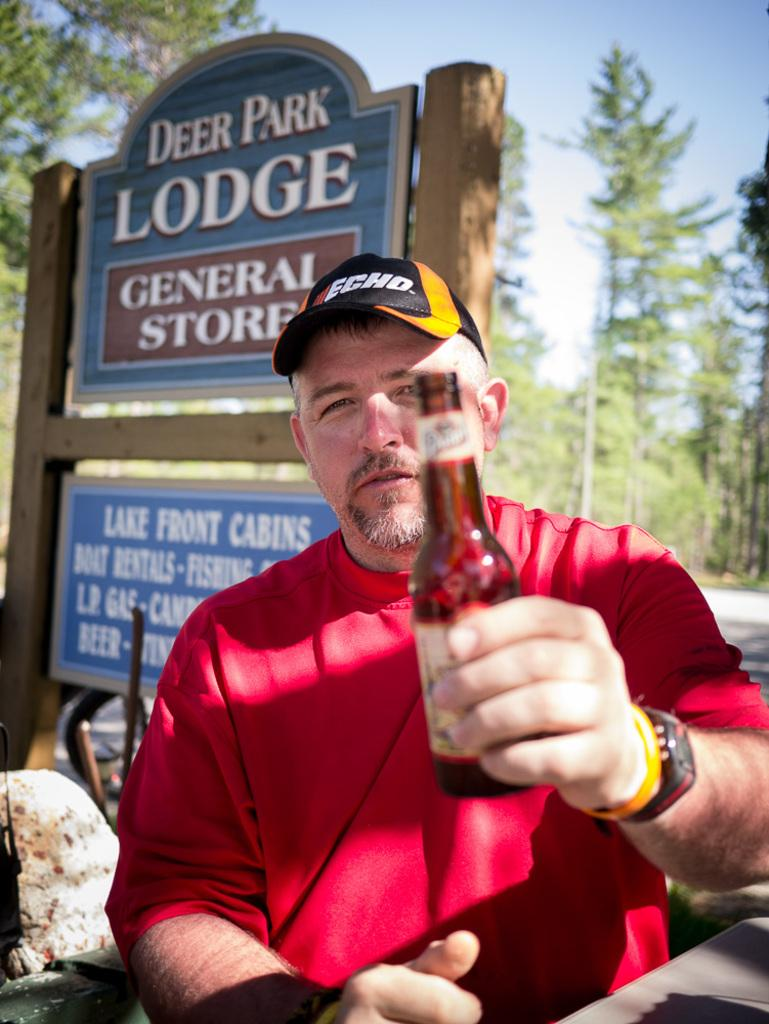What is the person in the image doing? The person is sitting in the image. What is the person holding in the image? The person is holding a bottle in the image. What type of headwear is the person wearing? The person is wearing a cap in the image. What can be seen in the background of the image? There is a board, trees, and the sky visible in the background of the image. What type of bucket is the person using to support their leg in the image? There is no bucket or leg support visible in the image. 